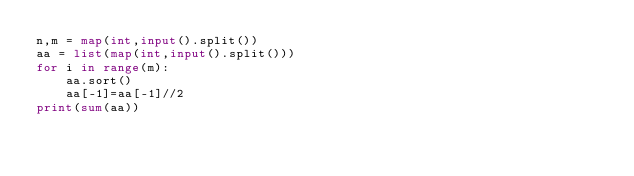Convert code to text. <code><loc_0><loc_0><loc_500><loc_500><_Python_>n,m = map(int,input().split())
aa = list(map(int,input().split()))
for i in range(m):
    aa.sort()
    aa[-1]=aa[-1]//2
print(sum(aa))
</code> 